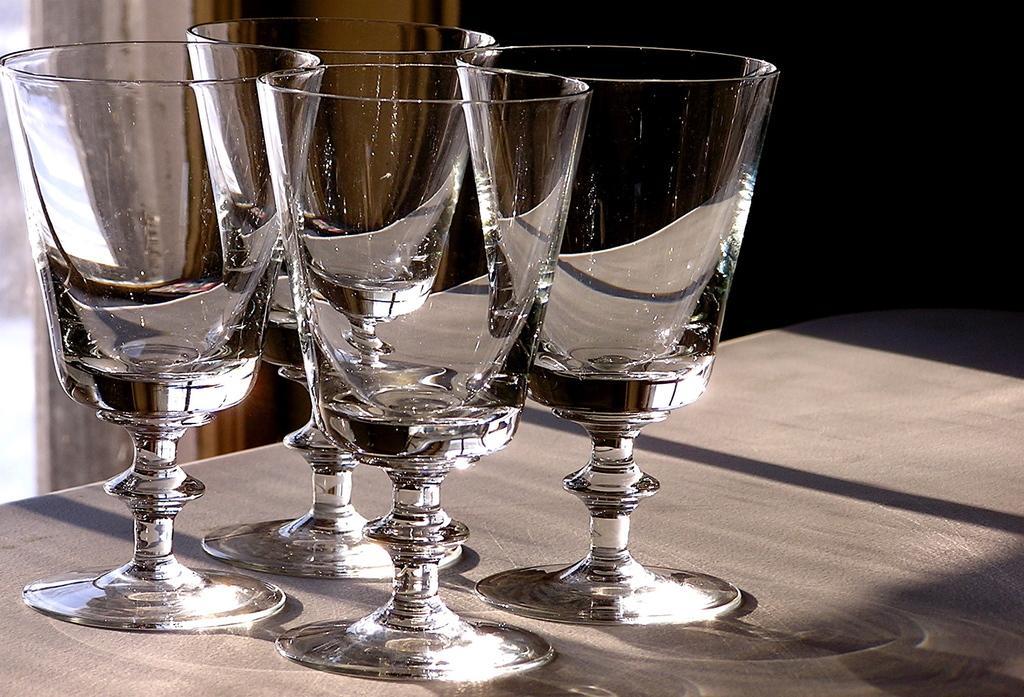Please provide a concise description of this image. In this image I can see four wine glasses on the grey colored surface and I can see the black colored background. 